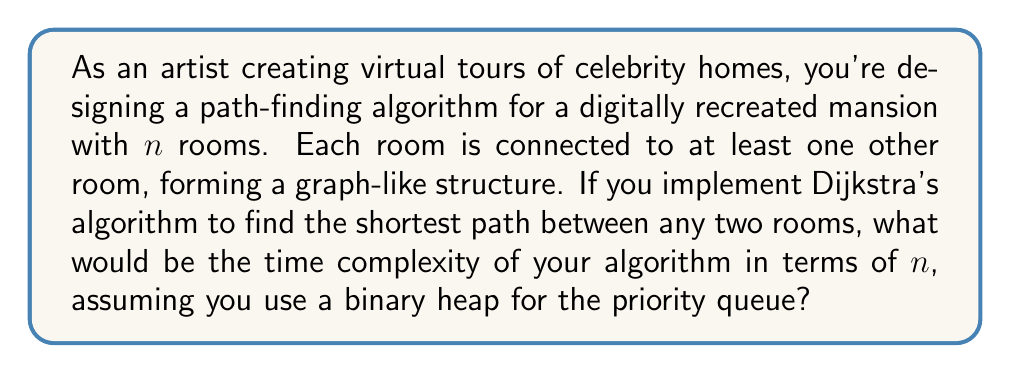Could you help me with this problem? To solve this problem, let's break down the implementation of Dijkstra's algorithm using a binary heap:

1. Graph representation:
   - The celebrity mansion can be represented as a graph with $n$ vertices (rooms) and $e$ edges (connections between rooms).
   - In the worst case, each room could be connected to every other room, giving us $e = O(n^2)$ edges.

2. Dijkstra's algorithm steps:
   a. Initialize distances: $O(n)$
   b. Build initial heap: $O(n)$
   c. Main loop: Runs $n$ times, once for each vertex
      - Extract minimum: $O(\log n)$
      - Update distances and heap: For each adjacent vertex (at most $n-1$), $O(\log n)$

3. Time complexity analysis:
   - Initialization: $O(n)$
   - Main loop: $O(n \cdot (\log n + (n-1) \cdot \log n))$
   - Simplified: $O(n \cdot (n \log n))$ = $O(n^2 \log n)$

4. Optimizations:
   - Using a binary heap reduces the time complexity from $O(n^2)$ (using an array) to $O(n^2 \log n)$.
   - This is because heap operations (insert and extract-min) take $O(\log n)$ time instead of $O(n)$.

5. Final analysis:
   The time complexity of Dijkstra's algorithm using a binary heap for a graph with $n$ vertices and potentially $O(n^2)$ edges is $O(n^2 \log n)$.

This time complexity allows for efficient path-finding in the virtual celebrity home tour, balancing performance with the potentially complex structure of the mansion.
Answer: The time complexity of Dijkstra's algorithm for path-finding in the digitally recreated celebrity home with $n$ rooms, using a binary heap for the priority queue, is $O(n^2 \log n)$. 